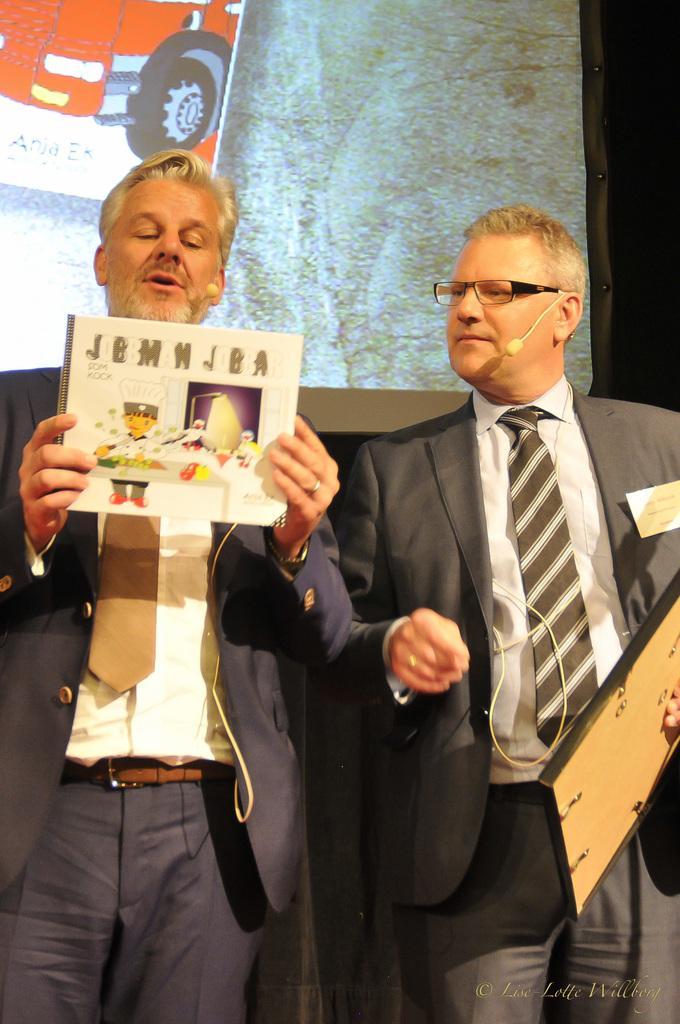In one or two sentences, can you explain what this image depicts? In this image we can see two men. They are wearing a suit and a tie. Here we can see a man on the right side and he is holding a photo frame in his left hand. Here we can see a man on the left side and he is holding a book in his hands and he is speaking on a microphone. In the background, we can see the screen. 